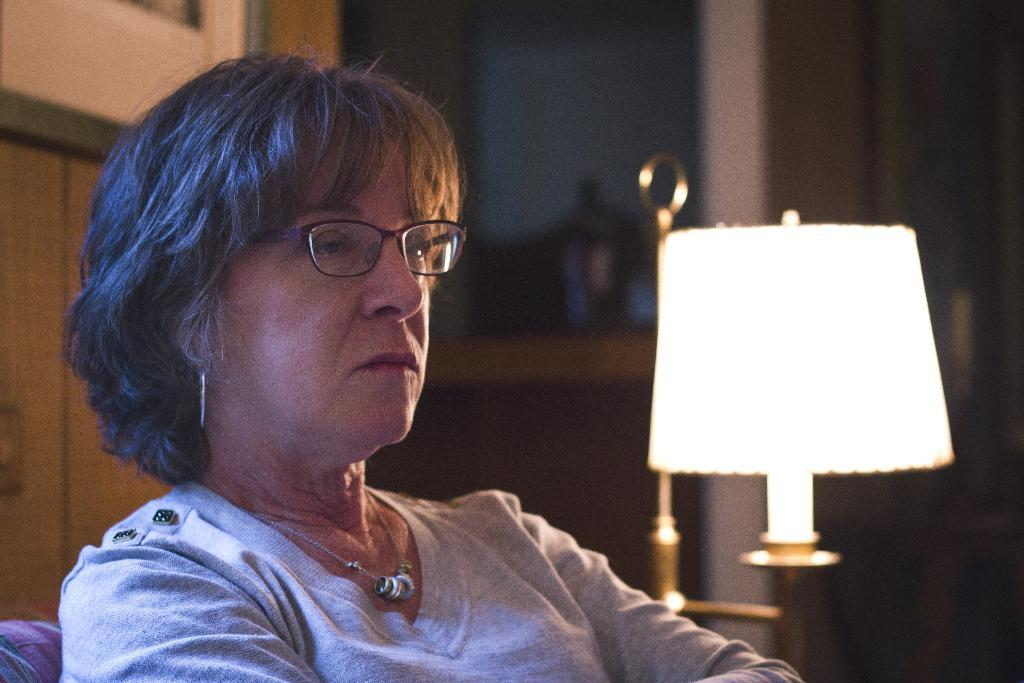Who is the main subject in the image? There is a woman in the image. What is the woman doing in the image? The woman is sitting on a sofa. What other objects can be seen in the image? There is a lamp in the image. What is the woman's area of expertise in the image? There is no information provided about the woman's expertise in the image. 